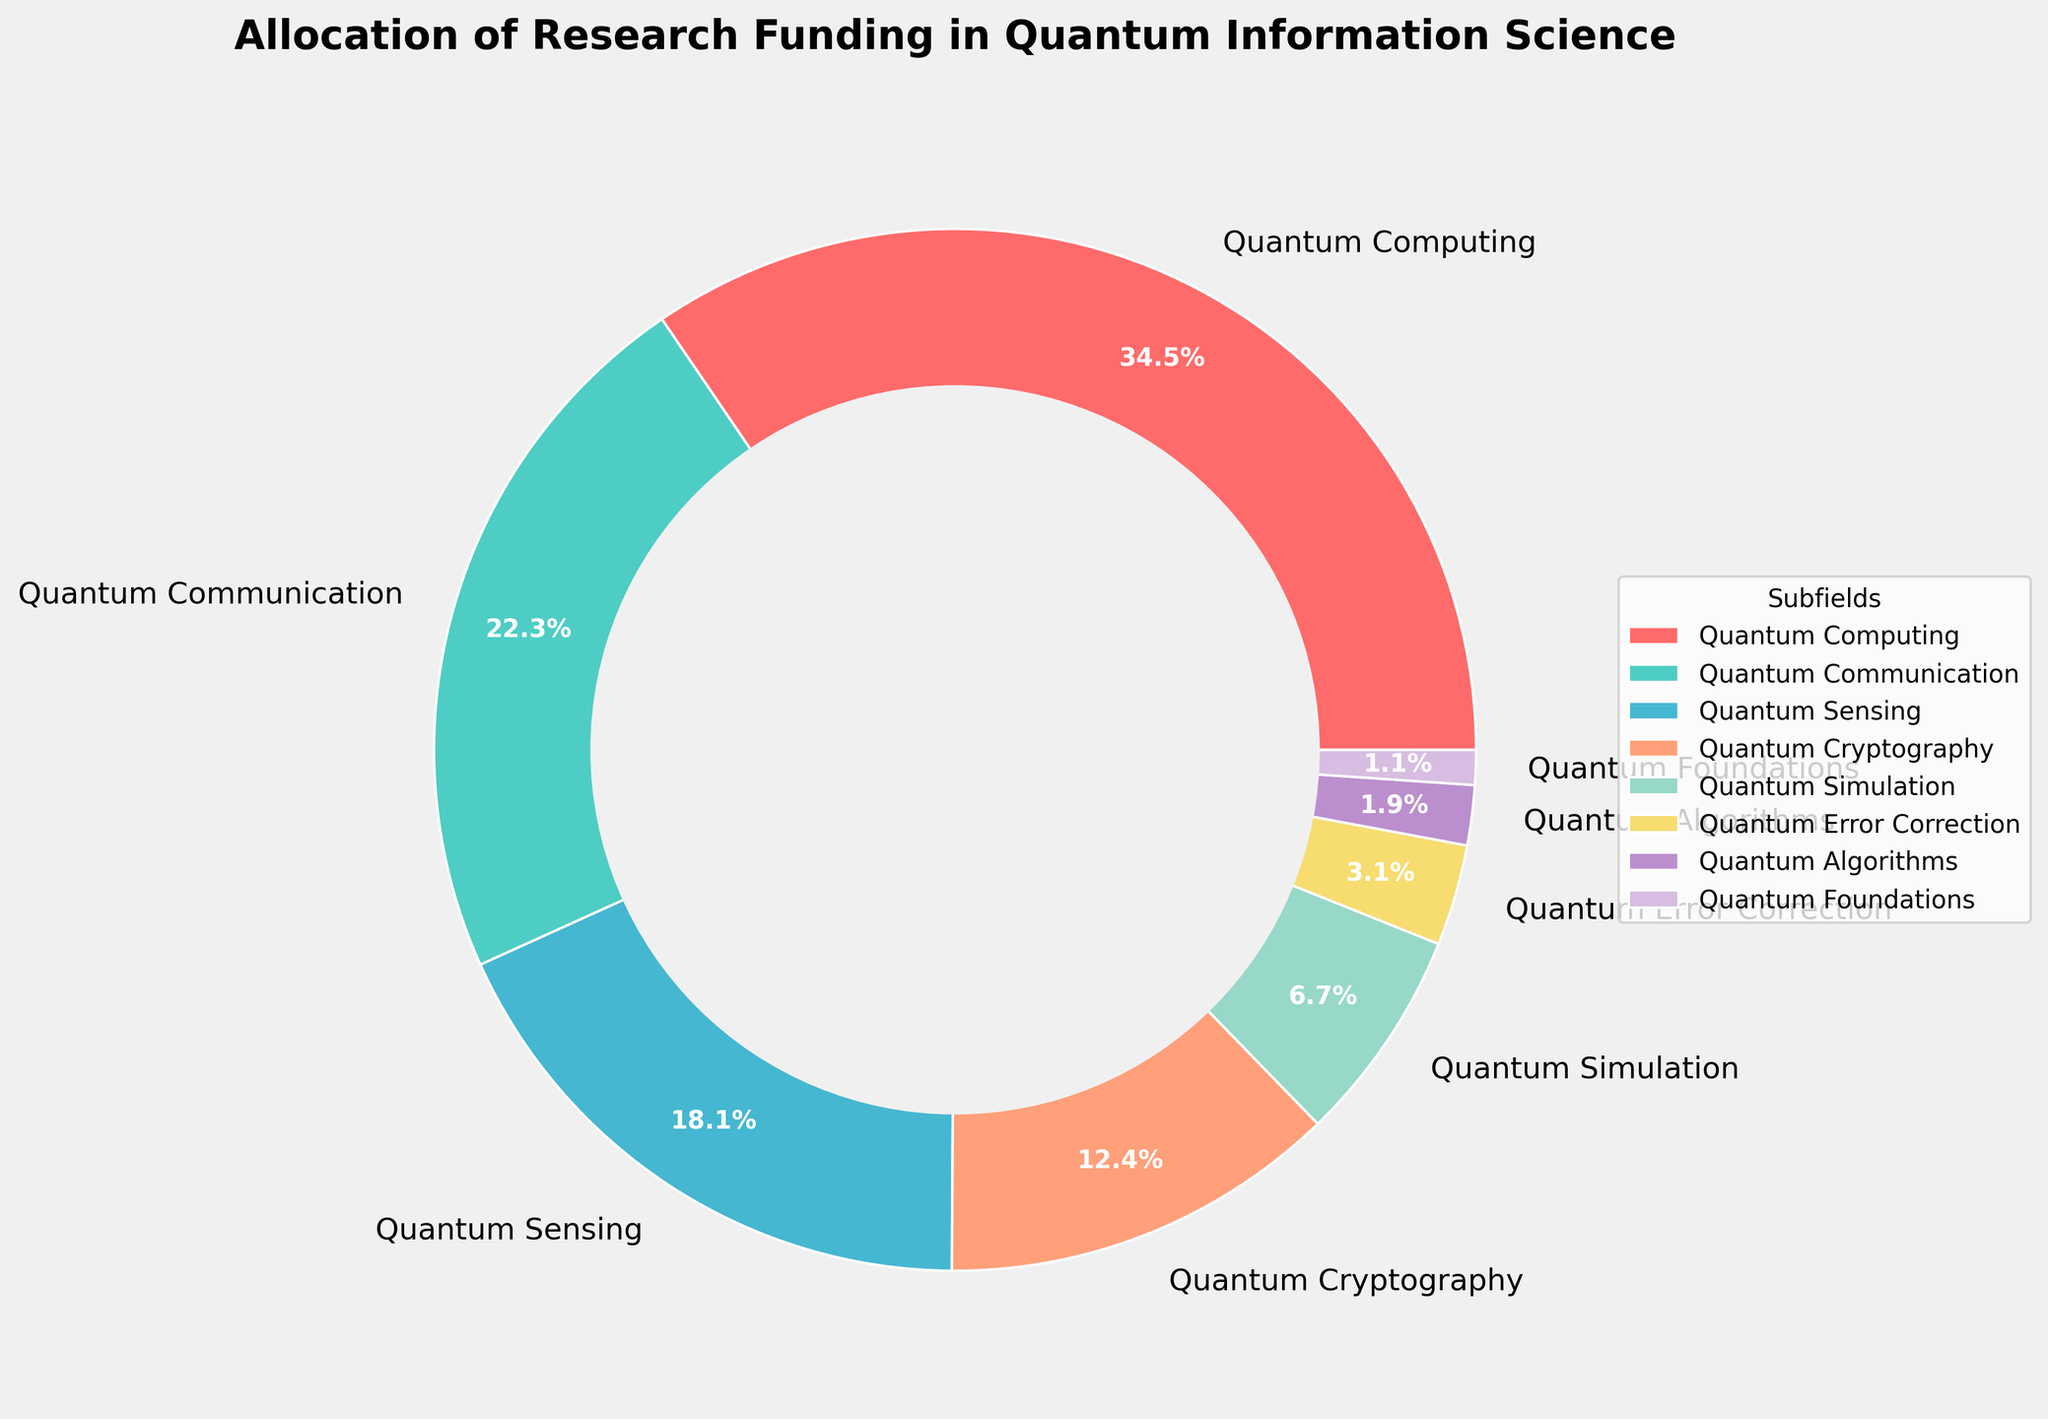What percentage of the funding is allocated to Quantum Communication and Quantum Sensing together? Add the funding percentages allocated to Quantum Communication (22.7%) and Quantum Sensing (18.5%) together: 22.7 + 18.5 = 41.2
Answer: 41.2% Which subfield receives the least amount of funding? The subfield with the smallest slice on the pie chart and the smallest label percentage is Quantum Foundations, which has a funding percentage of 1.1%.
Answer: Quantum Foundations How much more funding does Quantum Computing receive compared to Quantum Cryptography? Subtract the funding percentage allocated to Quantum Cryptography (12.6%) from Quantum Computing (35.2%): 35.2 - 12.6 = 22.6
Answer: 22.6% Is the funding for Quantum Error Correction greater than that for Quantum Algorithms? The funding percentage for Quantum Error Correction is 3.2%, which is greater than the 1.9% for Quantum Algorithms.
Answer: Yes What is the combined funding percentage for the subfields with the smallest three allocations? Add the funding percentages for Quantum Algorithms (1.9%), Quantum Foundations (1.1%), and Quantum Error Correction (3.2%): 1.9 + 1.1 + 3.2 = 6.2
Answer: 6.2% Which subfield has the second-highest funding allocation? The subfield with the second-largest slice on the pie chart after Quantum Computing is Quantum Communication, which has a funding percentage of 22.7%.
Answer: Quantum Communication Are there any subfields that receive equal funding? All percentages are different in the pie chart. Thus, no two subfields receive equal funding.
Answer: No What is the sum of the funding percentages for Quantum Sensing, Quantum Cryptography, and Quantum Simulation? Add the funding percentages for Quantum Sensing (18.5%), Quantum Cryptography (12.6%), and Quantum Simulation (6.8%): 18.5 + 12.6 + 6.8 = 37.9
Answer: 37.9% What color represents Quantum Sensing in the figure? The custom color assigned to Quantum Sensing is represented by the fifth listed color in the pie chart's visual information, which is a light greenish shade.
Answer: Light Green If you were to remove the funding for Quantum Foundations, what would be the new total funding percentage represented in the chart? Subtract the percentage of Quantum Foundations (1.1%) from the total 100%: 100 - 1.1 = 98.9
Answer: 98.9% 